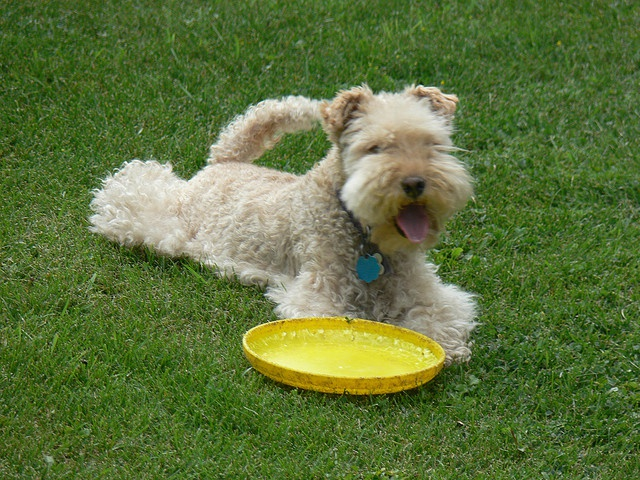Describe the objects in this image and their specific colors. I can see dog in darkgreen, darkgray, lightgray, and gray tones and frisbee in darkgreen, khaki, olive, and gold tones in this image. 